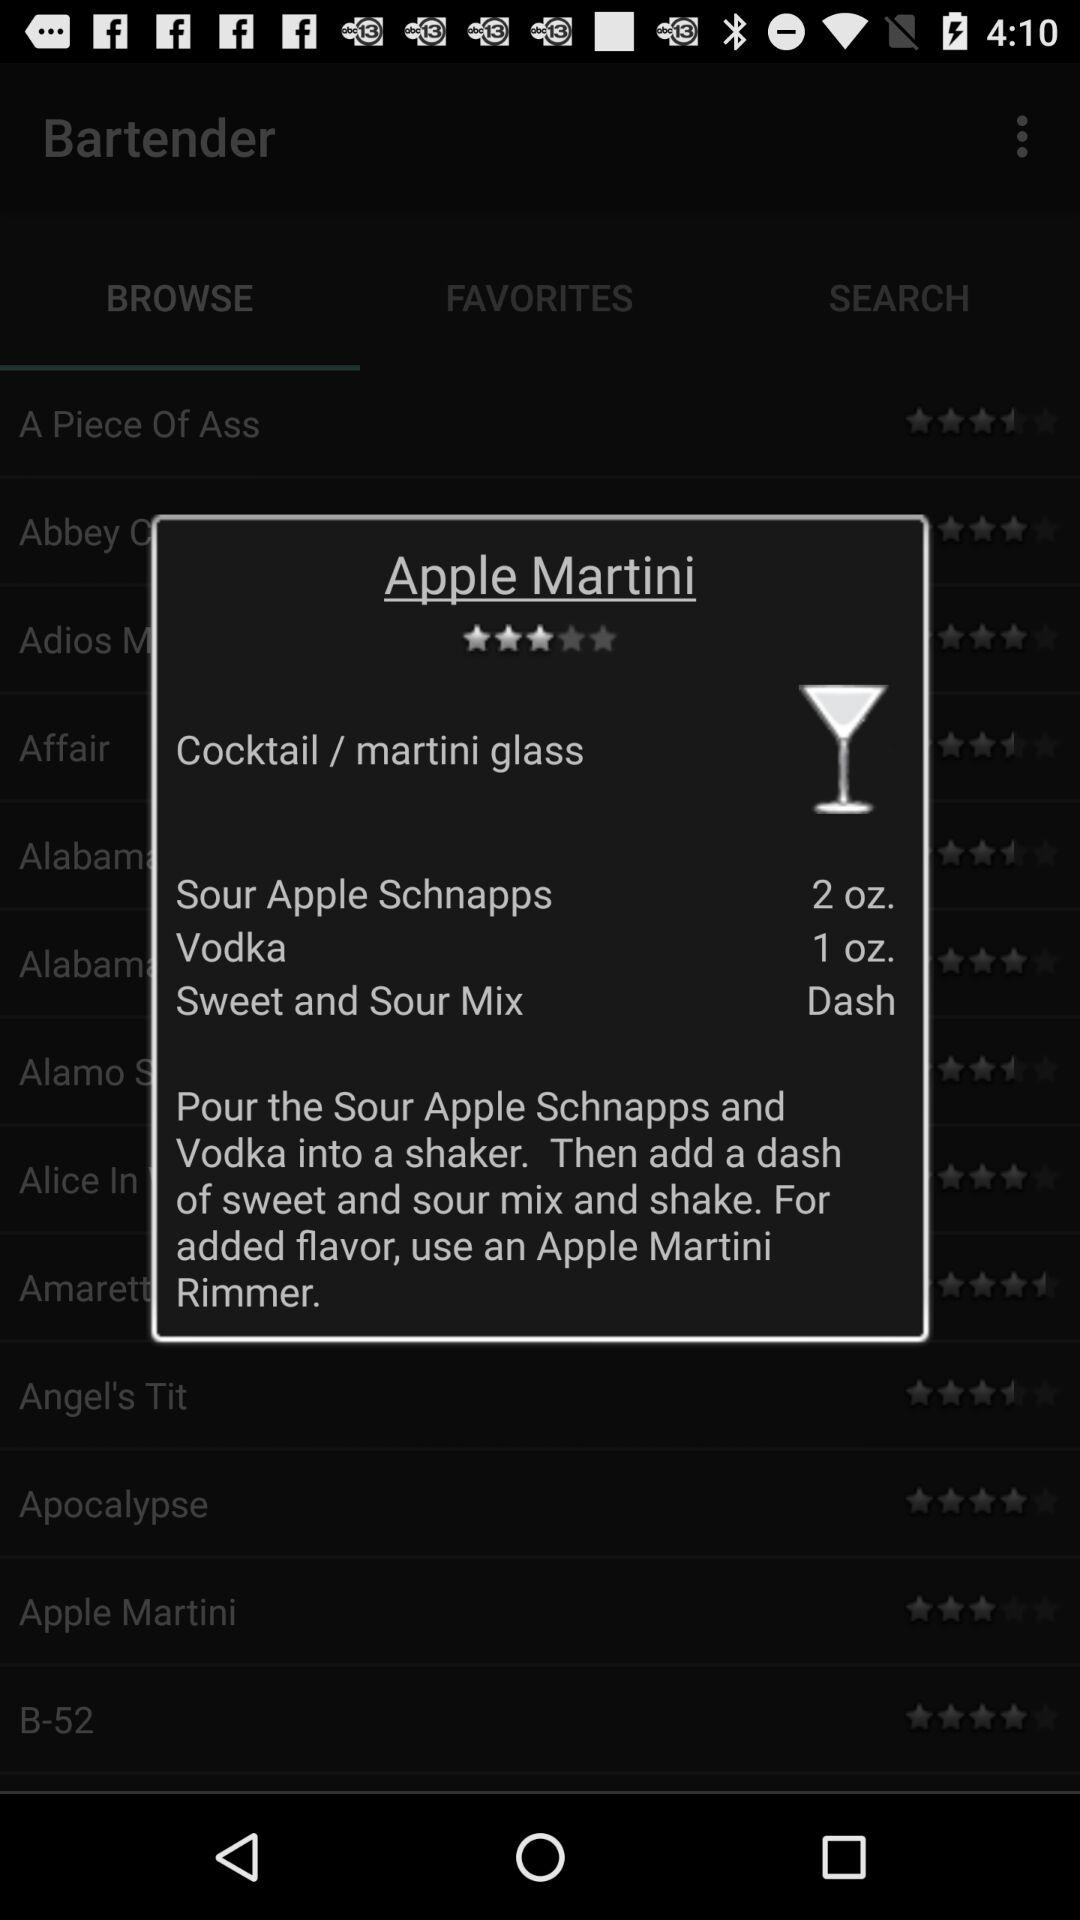What is the quantity of vodka? The quantity of vodka is 1 ounce. 